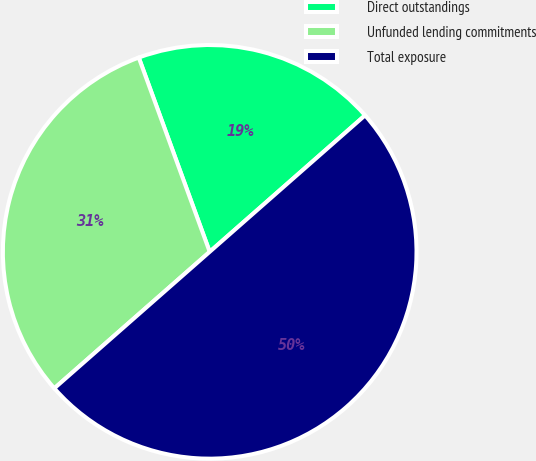<chart> <loc_0><loc_0><loc_500><loc_500><pie_chart><fcel>Direct outstandings<fcel>Unfunded lending commitments<fcel>Total exposure<nl><fcel>19.1%<fcel>30.9%<fcel>50.0%<nl></chart> 